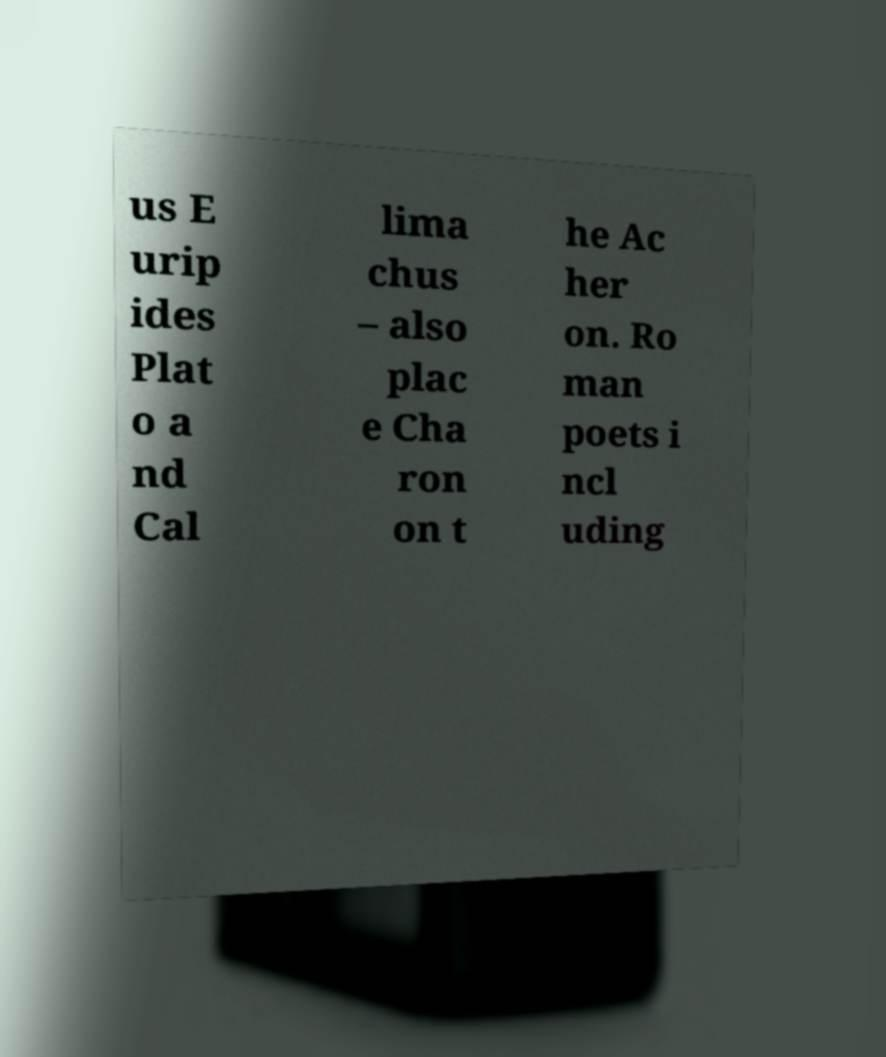For documentation purposes, I need the text within this image transcribed. Could you provide that? us E urip ides Plat o a nd Cal lima chus – also plac e Cha ron on t he Ac her on. Ro man poets i ncl uding 